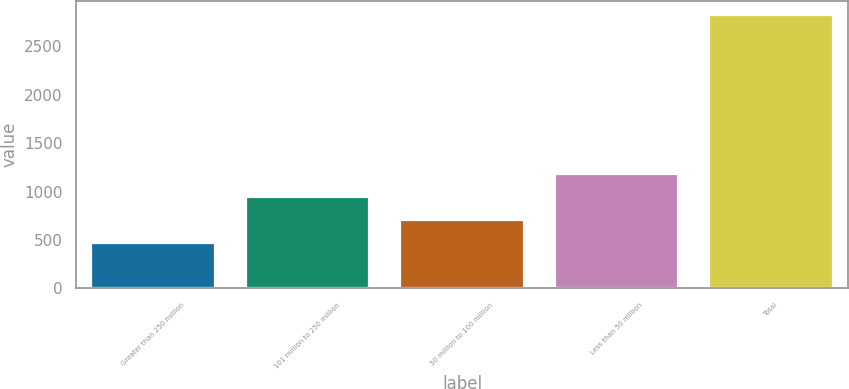Convert chart. <chart><loc_0><loc_0><loc_500><loc_500><bar_chart><fcel>Greater than 250 million<fcel>101 million to 250 million<fcel>50 million to 100 million<fcel>Less than 50 million<fcel>Total<nl><fcel>469<fcel>941.2<fcel>705.1<fcel>1177.3<fcel>2830<nl></chart> 